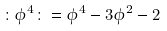Convert formula to latex. <formula><loc_0><loc_0><loc_500><loc_500>\colon \phi ^ { 4 } \colon = \phi ^ { 4 } - 3 \phi ^ { 2 } - 2</formula> 